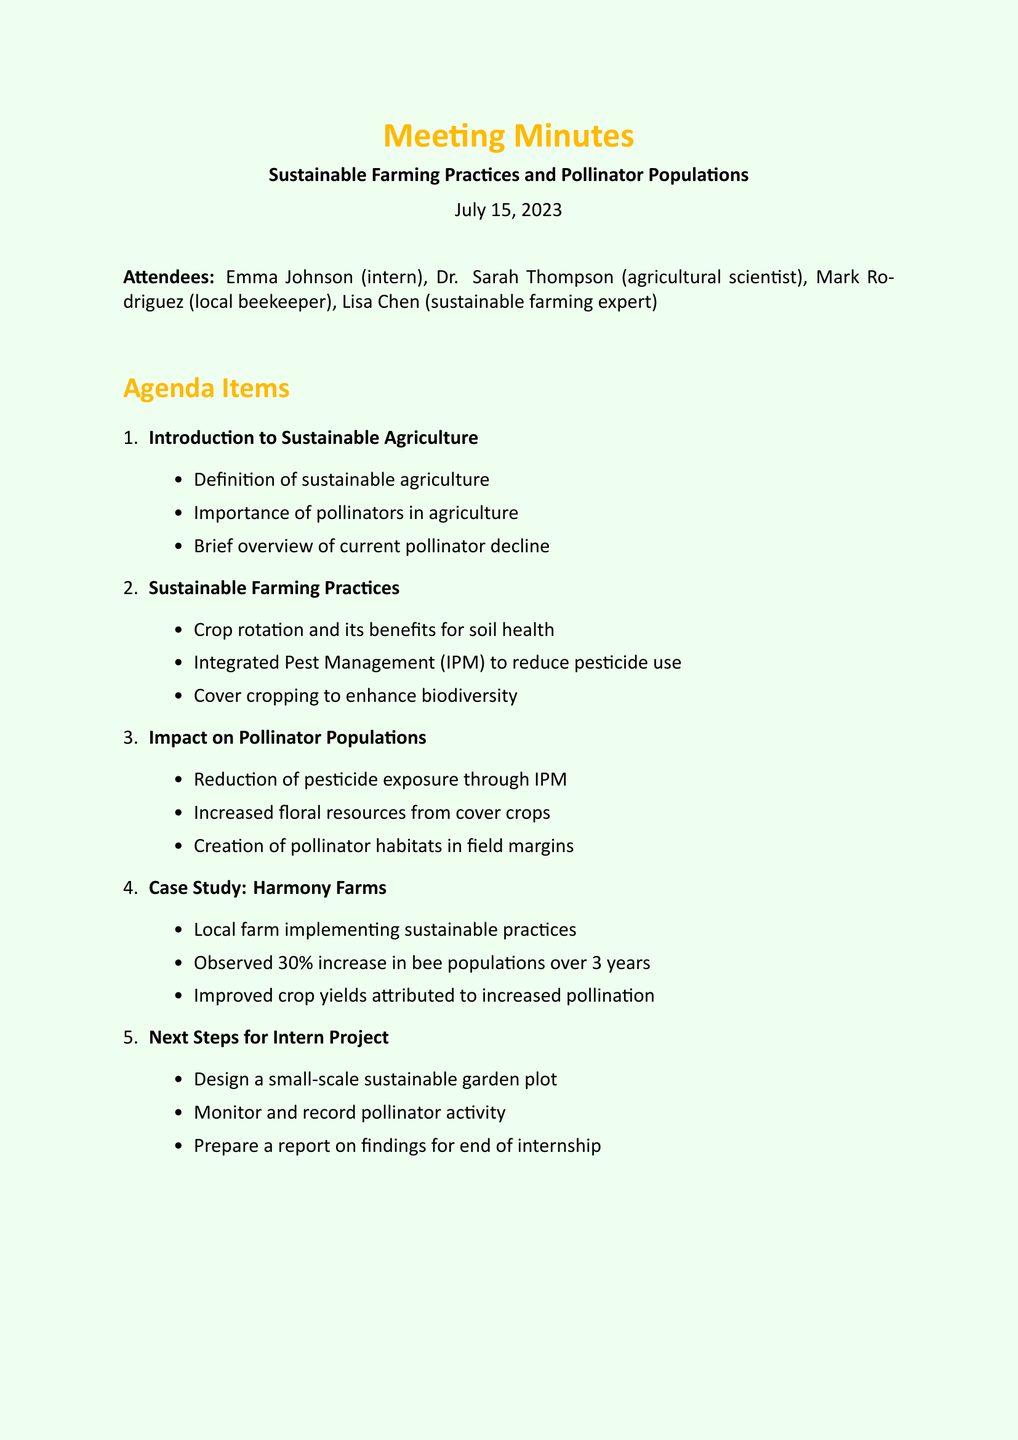What is the date of the meeting? The date of the meeting is explicitly stated in the document under the meeting title section.
Answer: July 15, 2023 Who is a local beekeeper mentioned in the meeting? The document lists attendees, among which Mark Rodriguez is identified as the local beekeeper.
Answer: Mark Rodriguez What percentage increase in bee populations was observed at Harmony Farms? The case study provides a specific percentage reflecting the increase in bee populations at Harmony Farms.
Answer: 30% What is one sustainable farming practice discussed in the meeting? The sustainable farming practices section mentions several key points, including crop rotation, which is one of the practices listed.
Answer: Crop rotation What are the next steps for the intern project? The document outlines specific tasks for the intern project, which includes designing a garden plot.
Answer: Design a small-scale sustainable garden plot What is the main focus of the meeting? The title of the meeting provides clarity on the overall topic being discussed, focusing on sustainable practices and their effects.
Answer: Sustainable Farming Practices and Pollinator Populations What type of farming practice is Integrated Pest Management? The document categorizes Integrated Pest Management as a sustainable farming practice aimed at reducing pesticide use.
Answer: Sustainable farming practice Who will arrange a visit to the apiary? The action items indicate that Mark is responsible for arranging this visit to his apiary.
Answer: Mark 